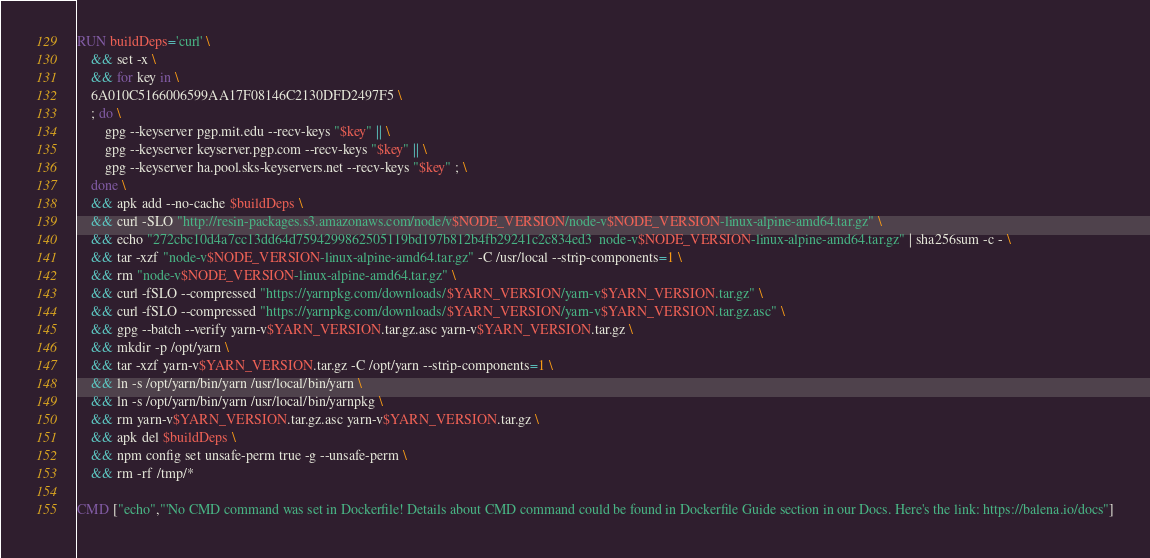Convert code to text. <code><loc_0><loc_0><loc_500><loc_500><_Dockerfile_>RUN buildDeps='curl' \
	&& set -x \
	&& for key in \
	6A010C5166006599AA17F08146C2130DFD2497F5 \
	; do \
		gpg --keyserver pgp.mit.edu --recv-keys "$key" || \
		gpg --keyserver keyserver.pgp.com --recv-keys "$key" || \
		gpg --keyserver ha.pool.sks-keyservers.net --recv-keys "$key" ; \
	done \
	&& apk add --no-cache $buildDeps \
	&& curl -SLO "http://resin-packages.s3.amazonaws.com/node/v$NODE_VERSION/node-v$NODE_VERSION-linux-alpine-amd64.tar.gz" \
	&& echo "272cbc10d4a7cc13dd64d7594299862505119bd197b812b4fb29241c2c834ed3  node-v$NODE_VERSION-linux-alpine-amd64.tar.gz" | sha256sum -c - \
	&& tar -xzf "node-v$NODE_VERSION-linux-alpine-amd64.tar.gz" -C /usr/local --strip-components=1 \
	&& rm "node-v$NODE_VERSION-linux-alpine-amd64.tar.gz" \
	&& curl -fSLO --compressed "https://yarnpkg.com/downloads/$YARN_VERSION/yarn-v$YARN_VERSION.tar.gz" \
	&& curl -fSLO --compressed "https://yarnpkg.com/downloads/$YARN_VERSION/yarn-v$YARN_VERSION.tar.gz.asc" \
	&& gpg --batch --verify yarn-v$YARN_VERSION.tar.gz.asc yarn-v$YARN_VERSION.tar.gz \
	&& mkdir -p /opt/yarn \
	&& tar -xzf yarn-v$YARN_VERSION.tar.gz -C /opt/yarn --strip-components=1 \
	&& ln -s /opt/yarn/bin/yarn /usr/local/bin/yarn \
	&& ln -s /opt/yarn/bin/yarn /usr/local/bin/yarnpkg \
	&& rm yarn-v$YARN_VERSION.tar.gz.asc yarn-v$YARN_VERSION.tar.gz \
	&& apk del $buildDeps \
	&& npm config set unsafe-perm true -g --unsafe-perm \
	&& rm -rf /tmp/*

CMD ["echo","'No CMD command was set in Dockerfile! Details about CMD command could be found in Dockerfile Guide section in our Docs. Here's the link: https://balena.io/docs"]</code> 